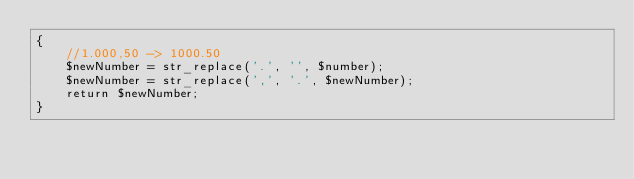<code> <loc_0><loc_0><loc_500><loc_500><_PHP_>{
    //1.000,50 -> 1000.50
    $newNumber = str_replace('.', '', $number);
    $newNumber = str_replace(',', '.', $newNumber);
    return $newNumber;
}
</code> 